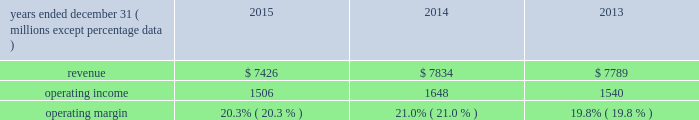( 2 ) in 2013 , our principal u.k subsidiary agreed with the trustees of one of the u.k .
Plans to contribute an average of $ 11 million per year to that pension plan for the next three years .
The trustees of the plan have certain rights to request that our u.k .
Subsidiary advance an amount equal to an actuarially determined winding-up deficit .
As of december 31 , 2015 , the estimated winding-up deficit was a3240 million ( $ 360 million at december 31 , 2015 exchange rates ) .
The trustees of the plan have accepted in practice the agreed-upon schedule of contributions detailed above and have not requested the winding-up deficit be paid .
( 3 ) purchase obligations are defined as agreements to purchase goods and services that are enforceable and legally binding on us , and that specifies all significant terms , including what is to be purchased , at what price and the approximate timing of the transaction .
Most of our purchase obligations are related to purchases of information technology services or other service contracts .
( 4 ) excludes $ 12 million of unfunded commitments related to an investment in a limited partnership due to our inability to reasonably estimate the period ( s ) when the limited partnership will request funding .
( 5 ) excludes $ 218 million of liabilities for uncertain tax positions due to our inability to reasonably estimate the period ( s ) when potential cash settlements will be made .
Financial condition at december 31 , 2015 , our net assets were $ 6.2 billion , representing total assets minus total liabilities , a decrease from $ 6.6 billion at december 31 , 2014 .
The decrease was due primarily to share repurchases of $ 1.6 billion , dividends of $ 323 million , and an increase in accumulated other comprehensive loss of $ 289 million related primarily to an increase in the post- retirement benefit obligation , partially offset by net income of $ 1.4 billion for the year ended december 31 , 2015 .
Working capital increased by $ 77 million from $ 809 million at december 31 , 2014 to $ 886 million at december 31 , 2015 .
Accumulated other comprehensive loss increased $ 289 million at december 31 , 2015 as compared to december 31 , 2014 , which was primarily driven by the following : 2022 negative net foreign currency translation adjustments of $ 436 million , which are attributable to the strengthening of the u.s .
Dollar against certain foreign currencies , 2022 a decrease of $ 155 million in net post-retirement benefit obligations , and 2022 net financial instrument losses of $ 8 million .
Review by segment general we serve clients through the following segments : 2022 risk solutions acts as an advisor and insurance and reinsurance broker , helping clients manage their risks , via consultation , as well as negotiation and placement of insurance risk with insurance carriers through our global distribution network .
2022 hr solutions partners with organizations to solve their most complex benefits , talent and related financial challenges , and improve business performance by designing , implementing , communicating and administering a wide range of human capital , retirement , investment management , health care , compensation and talent management strategies .
Risk solutions .
The demand for property and casualty insurance generally rises as the overall level of economic activity increases and generally falls as such activity decreases , affecting both the commissions and fees generated by our brokerage business .
The economic activity that impacts property and casualty insurance is described as exposure units , and is most closely correlated .
What is the working capital turnover in 2015? 
Computations: (7426 / ((809 + 886) / 2))
Answer: 8.76224. 